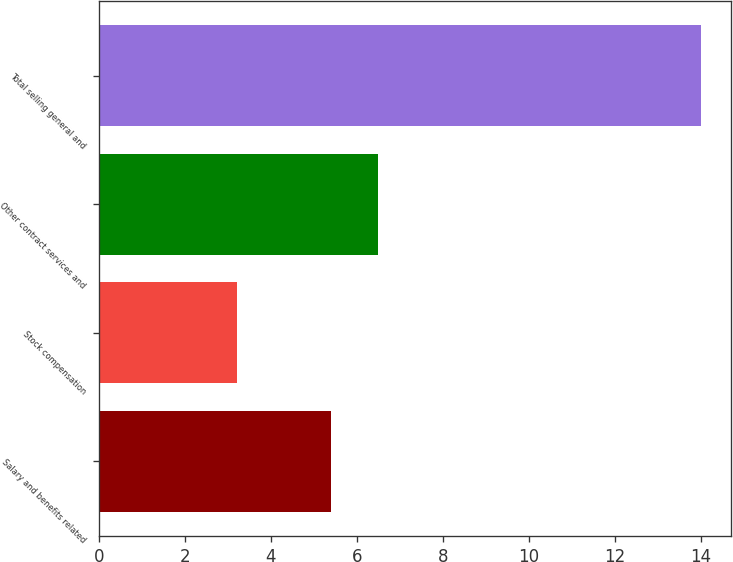Convert chart to OTSL. <chart><loc_0><loc_0><loc_500><loc_500><bar_chart><fcel>Salary and benefits related<fcel>Stock compensation<fcel>Other contract services and<fcel>Total selling general and<nl><fcel>5.4<fcel>3.2<fcel>6.48<fcel>14<nl></chart> 